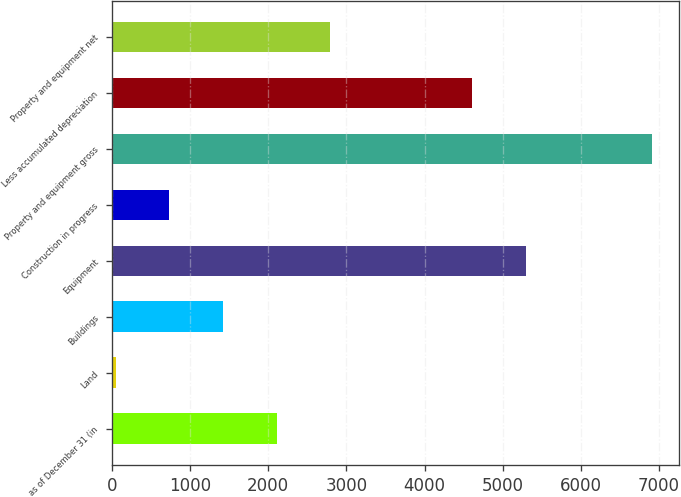Convert chart to OTSL. <chart><loc_0><loc_0><loc_500><loc_500><bar_chart><fcel>as of December 31 (in<fcel>Land<fcel>Buildings<fcel>Equipment<fcel>Construction in progress<fcel>Property and equipment gross<fcel>Less accumulated depreciation<fcel>Property and equipment net<nl><fcel>2107.7<fcel>50<fcel>1421.8<fcel>5296.9<fcel>735.9<fcel>6909<fcel>4611<fcel>2793.6<nl></chart> 